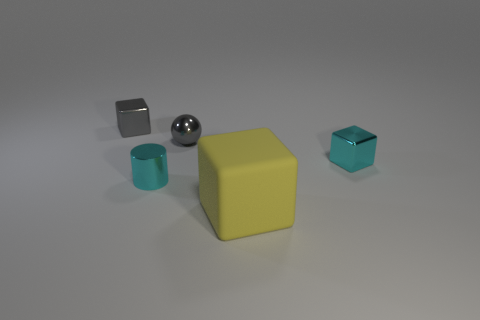Is there anything else that is made of the same material as the yellow thing?
Give a very brief answer. No. Is the size of the gray metal object that is on the left side of the shiny sphere the same as the tiny gray metallic sphere?
Offer a very short reply. Yes. What is the color of the small metal object that is to the right of the yellow block?
Provide a short and direct response. Cyan. What number of yellow rubber blocks are in front of the big yellow cube that is in front of the cyan shiny thing right of the large yellow matte thing?
Your response must be concise. 0. Are there fewer tiny cylinders on the left side of the cylinder than big yellow rubber cubes?
Your response must be concise. Yes. Do the ball and the small metal cylinder have the same color?
Offer a terse response. No. What is the size of the cyan shiny thing that is the same shape as the big yellow matte object?
Offer a very short reply. Small. What number of small cylinders are the same material as the tiny gray cube?
Keep it short and to the point. 1. Does the cyan object that is behind the small cyan metal cylinder have the same material as the small gray sphere?
Provide a short and direct response. Yes. Are there an equal number of tiny cylinders that are behind the tiny gray block and shiny spheres?
Make the answer very short. No. 